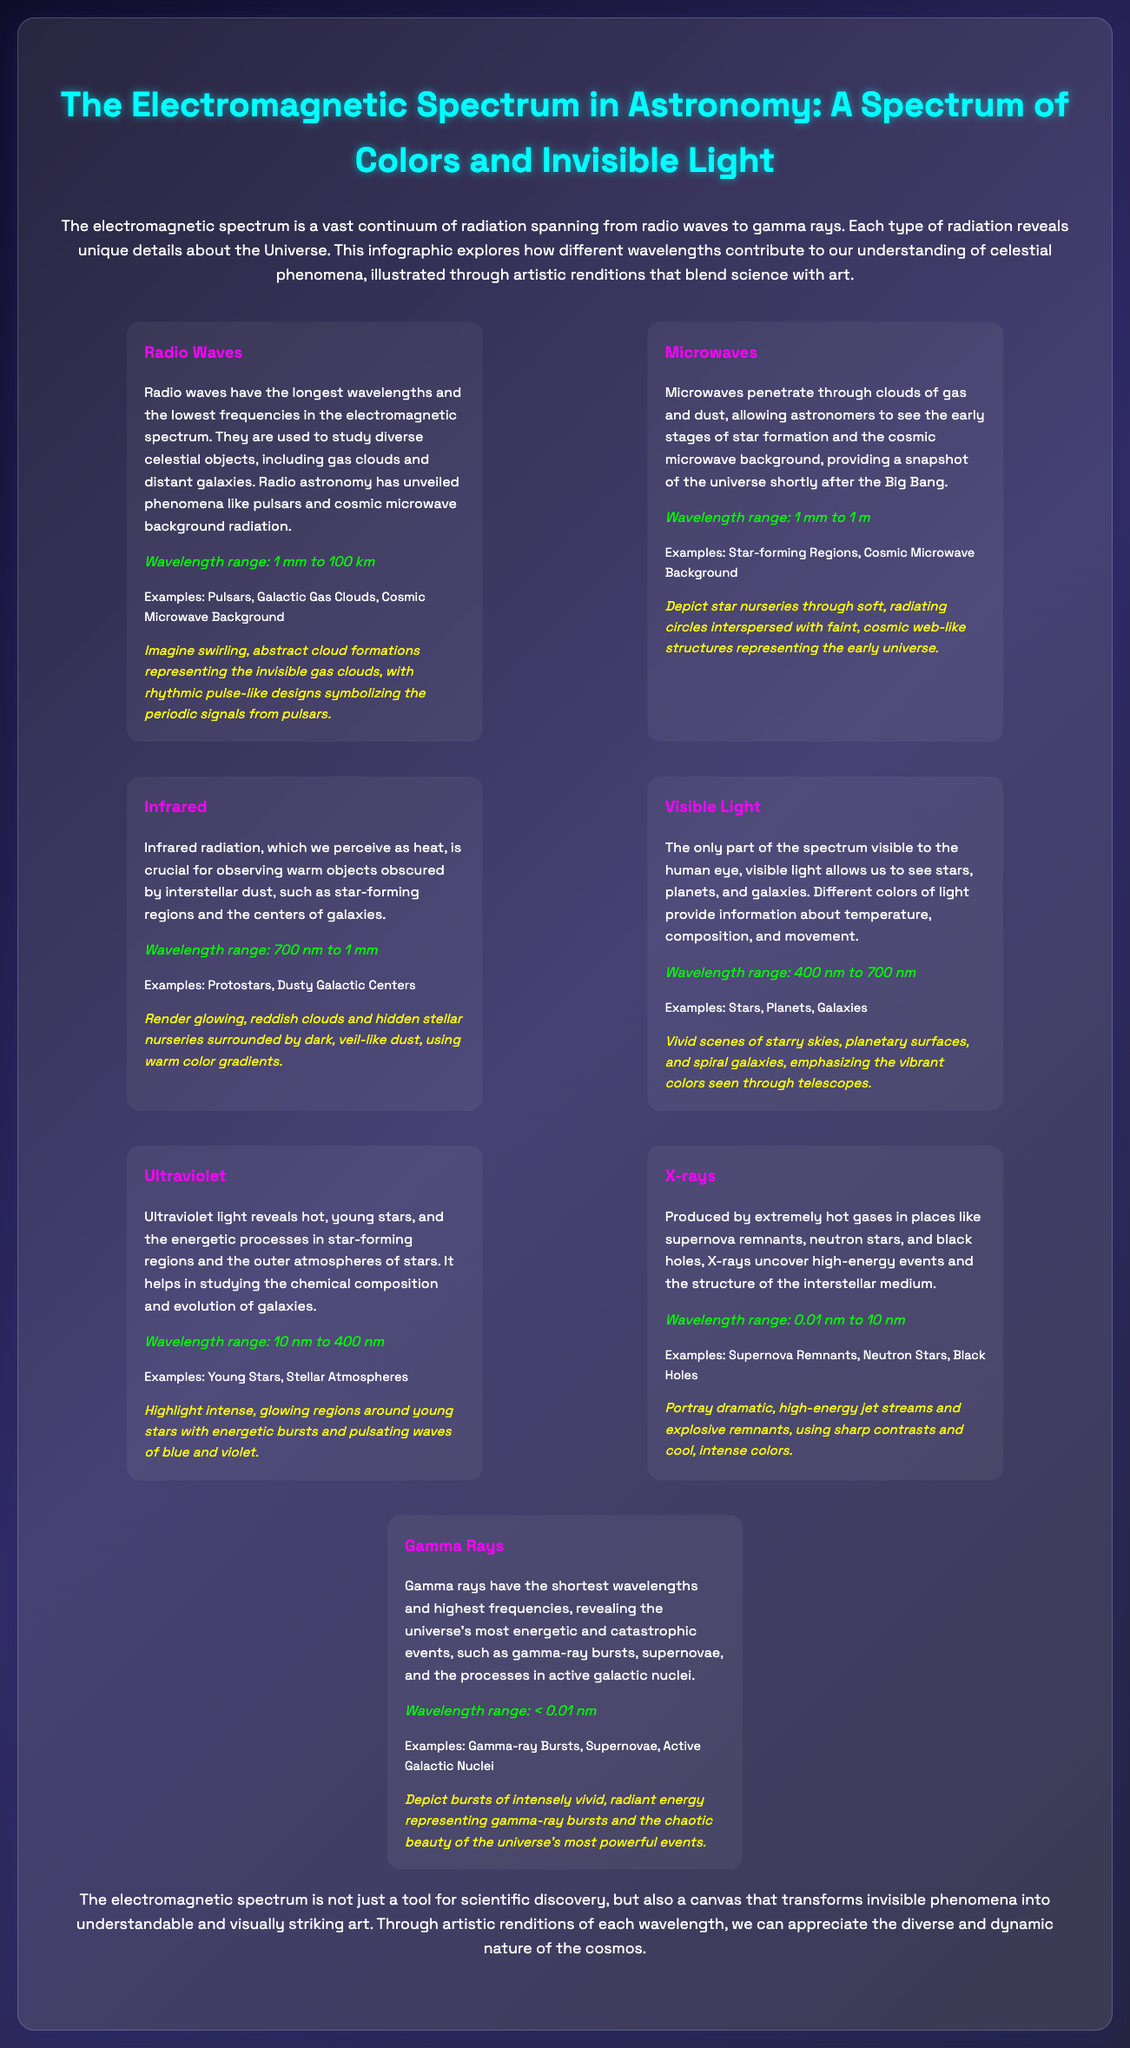What has the longest wavelengths? Radio waves have the longest wavelengths in the electromagnetic spectrum, as stated in the section about them.
Answer: Radio waves What is the wavelength range of X-rays? The wavelength range for X-rays is specified in the relevant section of the document.
Answer: 0.01 nm to 10 nm Which section includes artistic renditions of young stars? The section on Ultraviolet mentions young stars and provides an artistic rendition related to them.
Answer: Ultraviolet What types of phenomena do microwaves help to study? The document states that microwaves are used to study early stages of star formation and the cosmic microwave background.
Answer: Star-forming Regions, Cosmic Microwave Background How does the infographic describe gamma rays? The document mentions that gamma rays reveal energetic and catastrophic events in the universe.
Answer: Energetic and catastrophic events What color represents the glowing regions around young stars in the artistic representation? The artistic rendition in the Ultraviolet section highlights blue and violet colors around young stars.
Answer: Blue and violet What is emphasized in the conclusion? The conclusion highlights the relationship between the electromagnetic spectrum and visual art.
Answer: Transforming invisible phenomena into art 